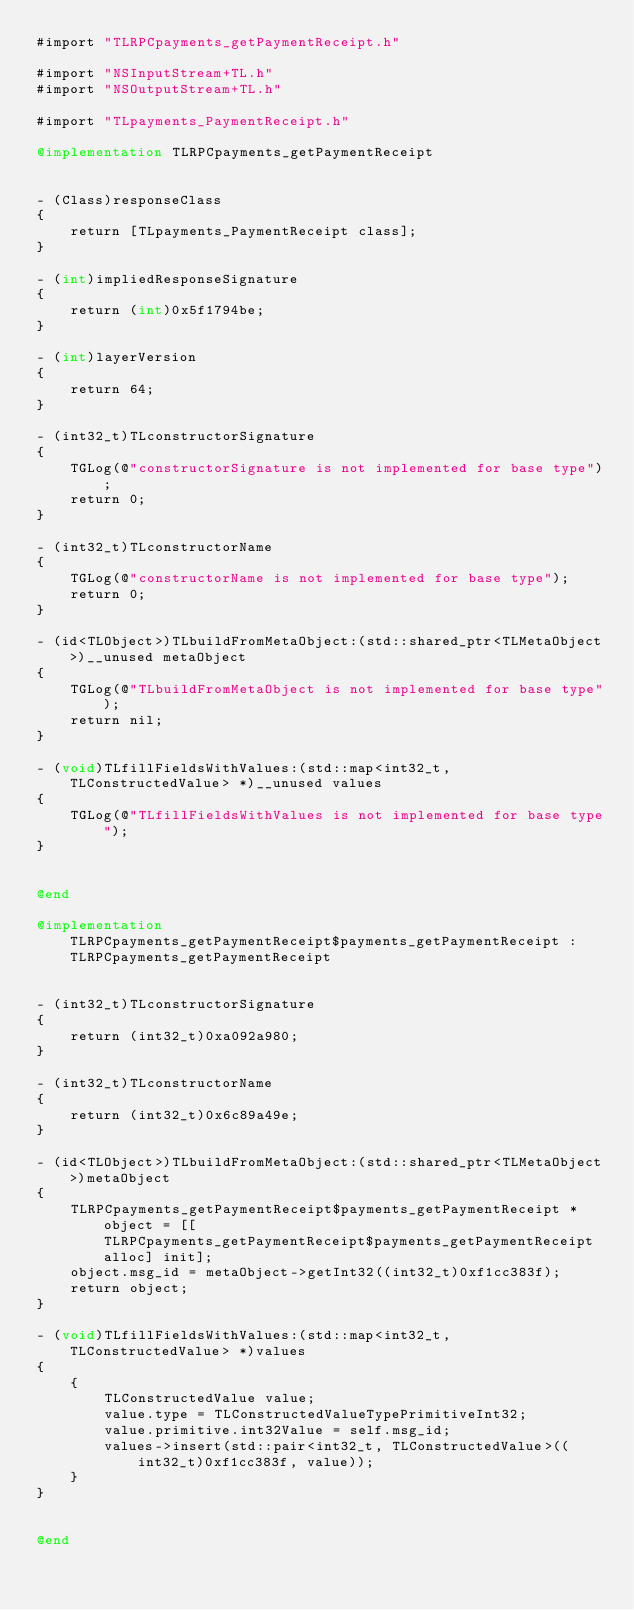Convert code to text. <code><loc_0><loc_0><loc_500><loc_500><_ObjectiveC_>#import "TLRPCpayments_getPaymentReceipt.h"

#import "NSInputStream+TL.h"
#import "NSOutputStream+TL.h"

#import "TLpayments_PaymentReceipt.h"

@implementation TLRPCpayments_getPaymentReceipt


- (Class)responseClass
{
    return [TLpayments_PaymentReceipt class];
}

- (int)impliedResponseSignature
{
    return (int)0x5f1794be;
}

- (int)layerVersion
{
    return 64;
}

- (int32_t)TLconstructorSignature
{
    TGLog(@"constructorSignature is not implemented for base type");
    return 0;
}

- (int32_t)TLconstructorName
{
    TGLog(@"constructorName is not implemented for base type");
    return 0;
}

- (id<TLObject>)TLbuildFromMetaObject:(std::shared_ptr<TLMetaObject>)__unused metaObject
{
    TGLog(@"TLbuildFromMetaObject is not implemented for base type");
    return nil;
}

- (void)TLfillFieldsWithValues:(std::map<int32_t, TLConstructedValue> *)__unused values
{
    TGLog(@"TLfillFieldsWithValues is not implemented for base type");
}


@end

@implementation TLRPCpayments_getPaymentReceipt$payments_getPaymentReceipt : TLRPCpayments_getPaymentReceipt


- (int32_t)TLconstructorSignature
{
    return (int32_t)0xa092a980;
}

- (int32_t)TLconstructorName
{
    return (int32_t)0x6c89a49e;
}

- (id<TLObject>)TLbuildFromMetaObject:(std::shared_ptr<TLMetaObject>)metaObject
{
    TLRPCpayments_getPaymentReceipt$payments_getPaymentReceipt *object = [[TLRPCpayments_getPaymentReceipt$payments_getPaymentReceipt alloc] init];
    object.msg_id = metaObject->getInt32((int32_t)0xf1cc383f);
    return object;
}

- (void)TLfillFieldsWithValues:(std::map<int32_t, TLConstructedValue> *)values
{
    {
        TLConstructedValue value;
        value.type = TLConstructedValueTypePrimitiveInt32;
        value.primitive.int32Value = self.msg_id;
        values->insert(std::pair<int32_t, TLConstructedValue>((int32_t)0xf1cc383f, value));
    }
}


@end

</code> 